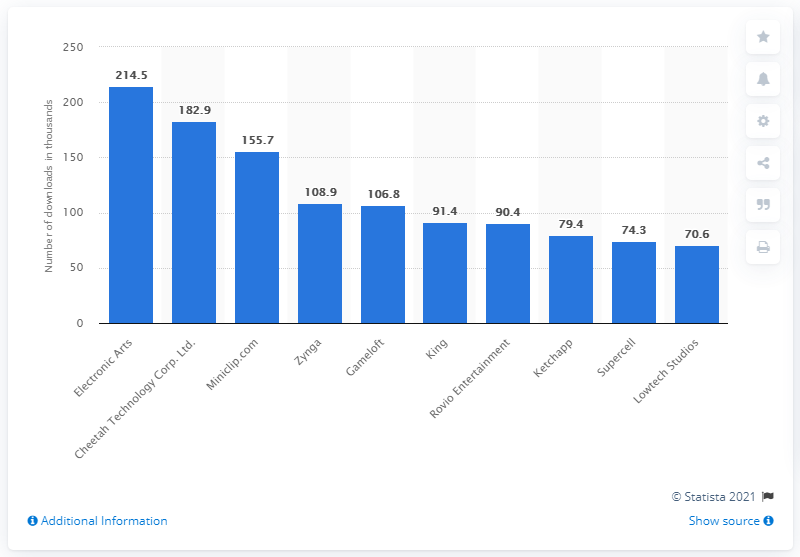Mention a couple of crucial points in this snapshot. The fourth most popular mobile game publisher was Zynga. Electronic Arts was the leader in the ranking. 